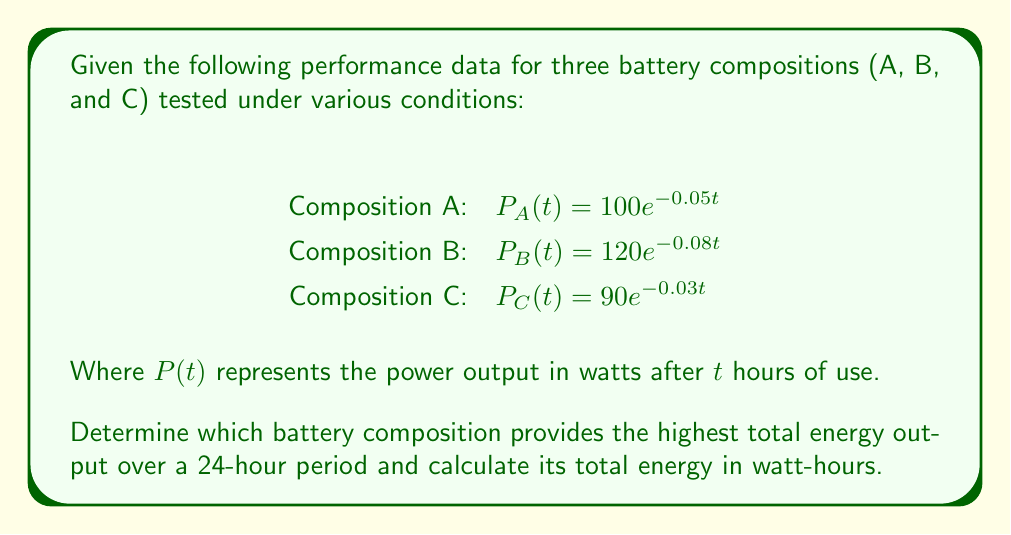Provide a solution to this math problem. To solve this problem, we need to follow these steps:

1) The energy output is the integral of the power function over time. For each composition, we need to integrate $P(t)$ from 0 to 24 hours.

2) For composition A:
   $E_A = \int_0^{24} 100e^{-0.05t} dt$
   $= -2000e^{-0.05t}|_0^{24}$
   $= -2000(e^{-1.2} - 1)$
   $= 1391.47$ watt-hours

3) For composition B:
   $E_B = \int_0^{24} 120e^{-0.08t} dt$
   $= -1500e^{-0.08t}|_0^{24}$
   $= -1500(e^{-1.92} - 1)$
   $= 1288.28$ watt-hours

4) For composition C:
   $E_C = \int_0^{24} 90e^{-0.03t} dt$
   $= -3000e^{-0.03t}|_0^{24}$
   $= -3000(e^{-0.72} - 1)$
   $= 1461.17$ watt-hours

5) Comparing the results, composition C provides the highest total energy output over 24 hours.
Answer: Composition C; 1461.17 watt-hours 